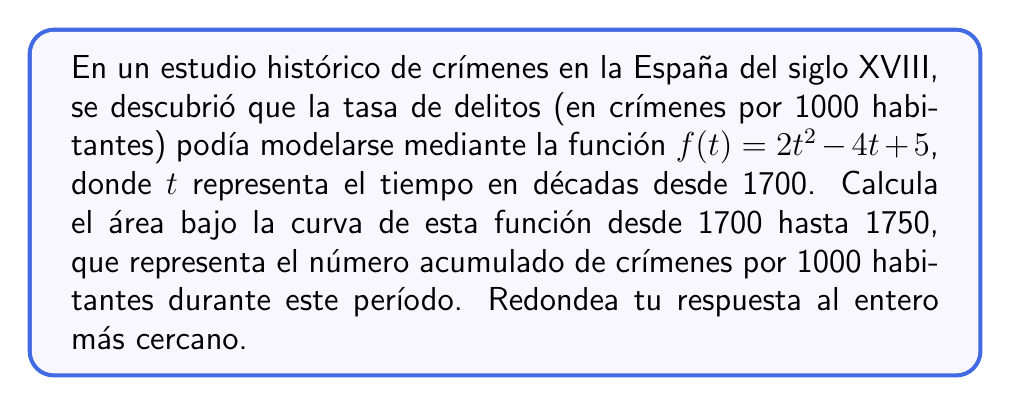Could you help me with this problem? Para resolver este problema, seguiremos estos pasos:

1) Primero, necesitamos establecer los límites de integración. Como $t$ representa décadas desde 1700, el período de 1700 a 1750 corresponde a $t=0$ hasta $t=5$.

2) La función a integrar es $f(t) = 2t^2 - 4t + 5$.

3) Usaremos la integral definida:

   $$\int_0^5 (2t^2 - 4t + 5) dt$$

4) Integramos término por término:
   
   $$\int_0^5 2t^2 dt - \int_0^5 4t dt + \int_0^5 5 dt$$

5) Aplicamos las reglas de integración:

   $$\left[\frac{2t^3}{3}\right]_0^5 - \left[2t^2\right]_0^5 + \left[5t\right]_0^5$$

6) Evaluamos en los límites:

   $$\left(\frac{2(5^3)}{3} - \frac{2(0^3)}{3}\right) - (2(5^2) - 2(0^2)) + (5(5) - 5(0))$$

7) Calculamos:

   $$\frac{250}{3} - 50 + 25$$

8) Simplificamos:

   $$\frac{250}{3} - 25 = \frac{175}{3} \approx 58.33$$

9) Redondeamos al entero más cercano: 58

Este resultado representa el número acumulado de crímenes por 1000 habitantes durante el período de 1700 a 1750 según el modelo dado.
Answer: 58 crímenes acumulados por 1000 habitantes 